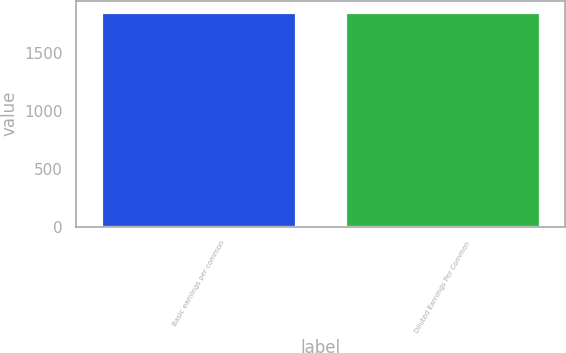Convert chart. <chart><loc_0><loc_0><loc_500><loc_500><bar_chart><fcel>Basic earnings per common<fcel>Diluted Earnings Per Common<nl><fcel>1855<fcel>1855.1<nl></chart> 